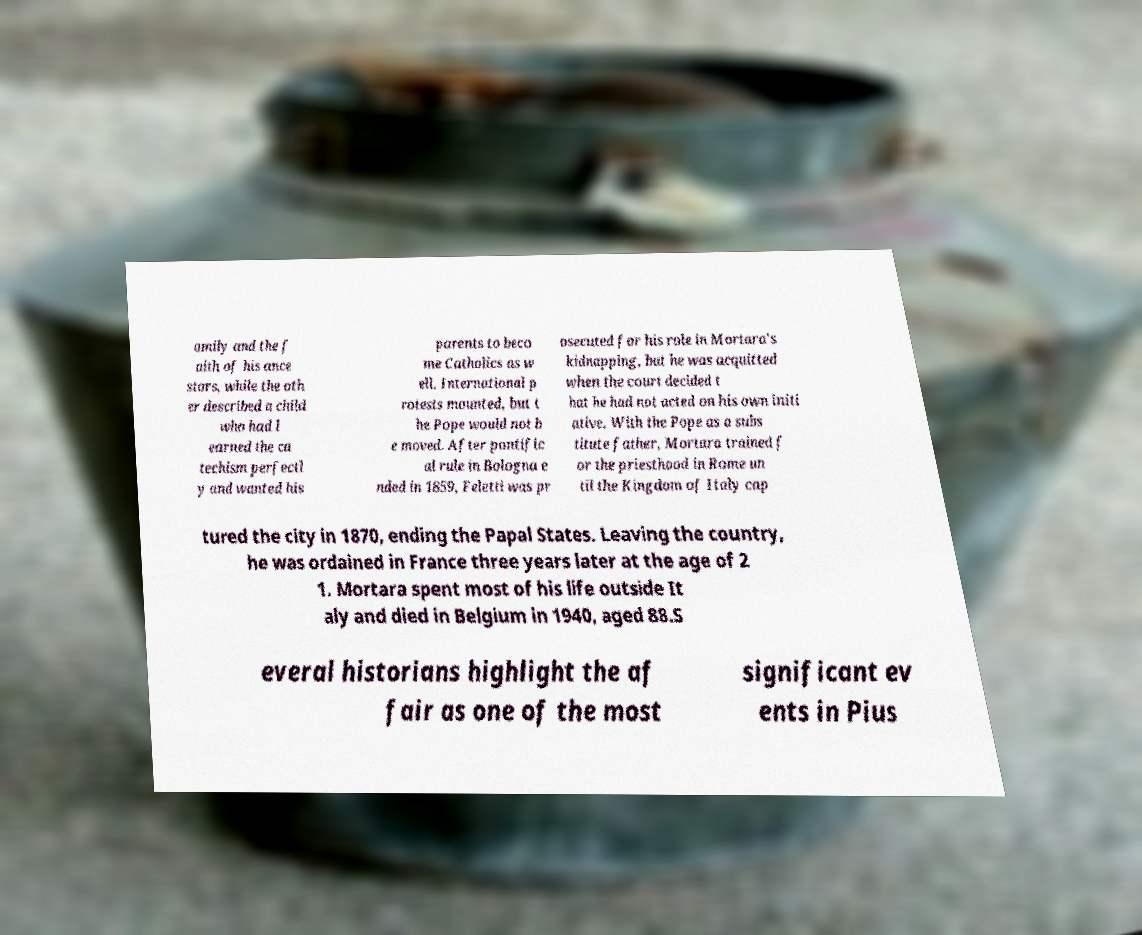There's text embedded in this image that I need extracted. Can you transcribe it verbatim? amily and the f aith of his ance stors, while the oth er described a child who had l earned the ca techism perfectl y and wanted his parents to beco me Catholics as w ell. International p rotests mounted, but t he Pope would not b e moved. After pontific al rule in Bologna e nded in 1859, Feletti was pr osecuted for his role in Mortara's kidnapping, but he was acquitted when the court decided t hat he had not acted on his own initi ative. With the Pope as a subs titute father, Mortara trained f or the priesthood in Rome un til the Kingdom of Italy cap tured the city in 1870, ending the Papal States. Leaving the country, he was ordained in France three years later at the age of 2 1. Mortara spent most of his life outside It aly and died in Belgium in 1940, aged 88.S everal historians highlight the af fair as one of the most significant ev ents in Pius 